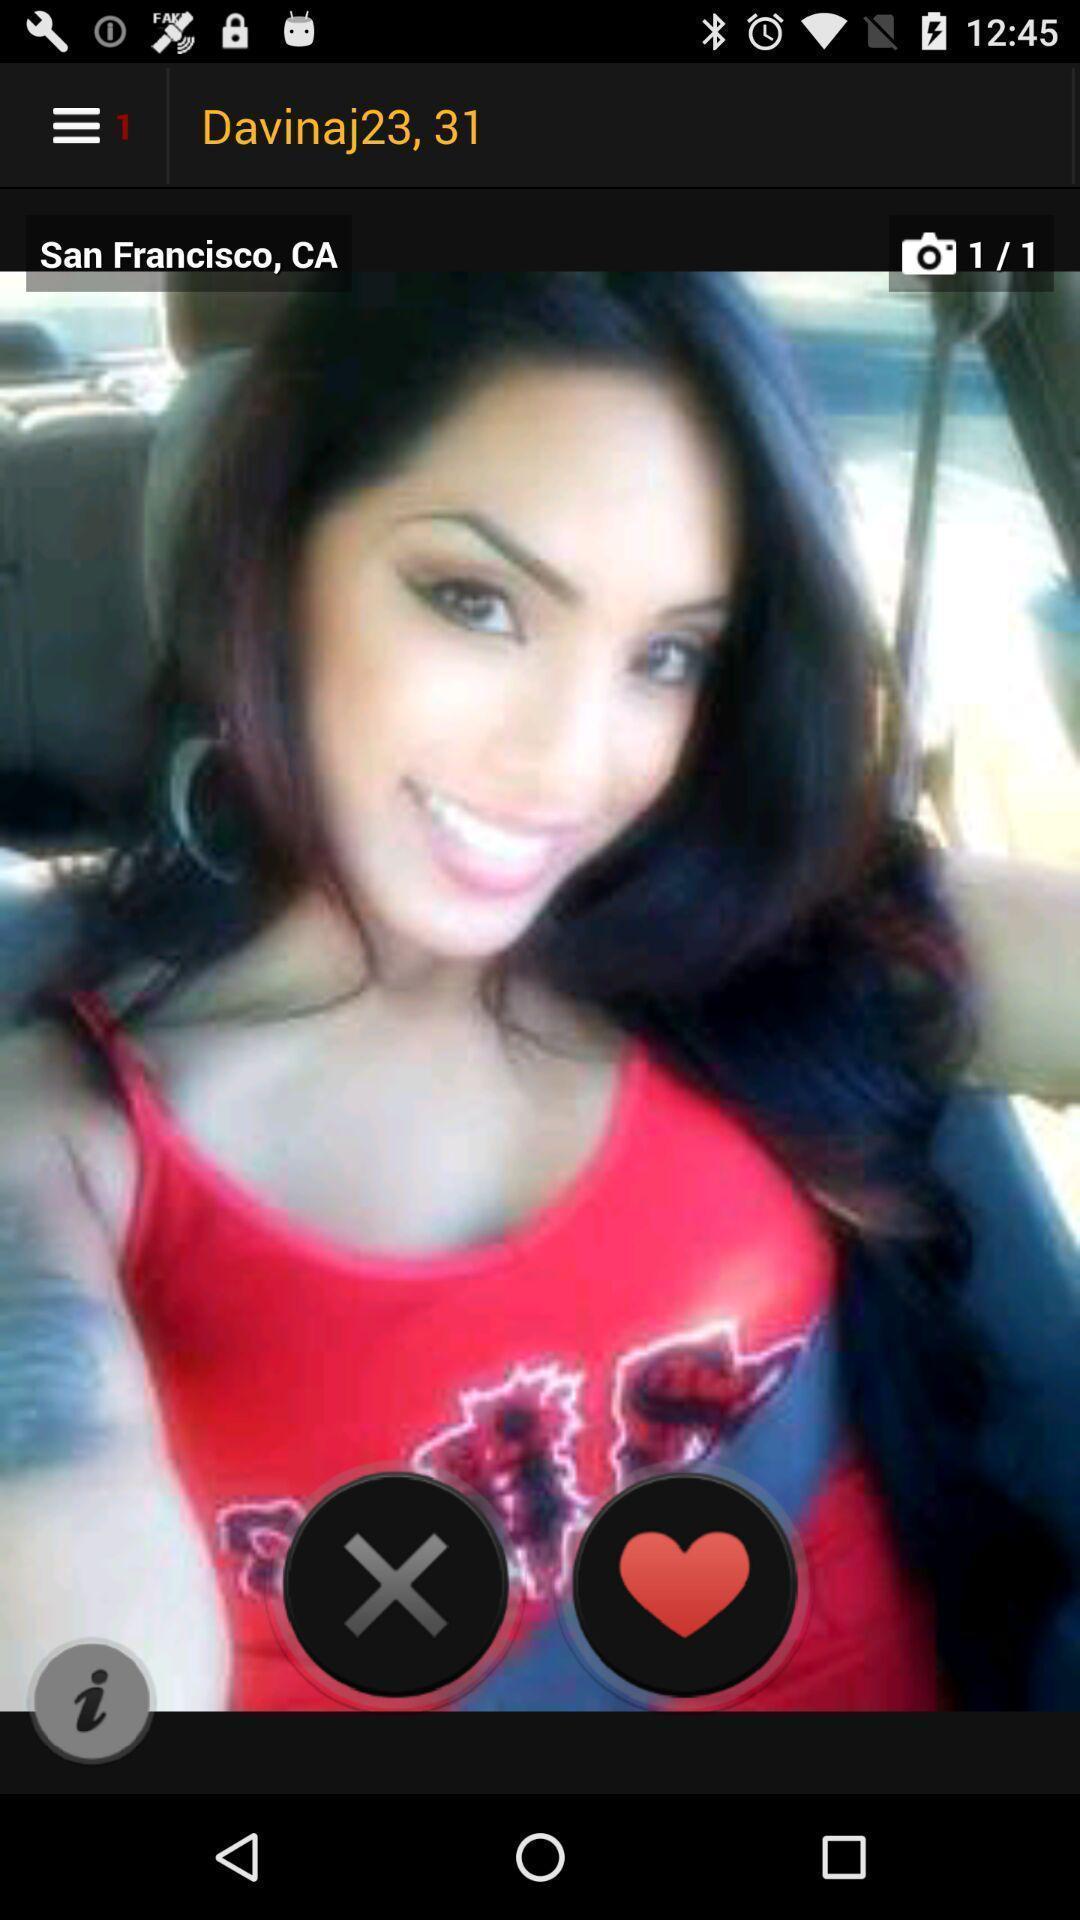Tell me about the visual elements in this screen capture. Screen showing page of an social application. 